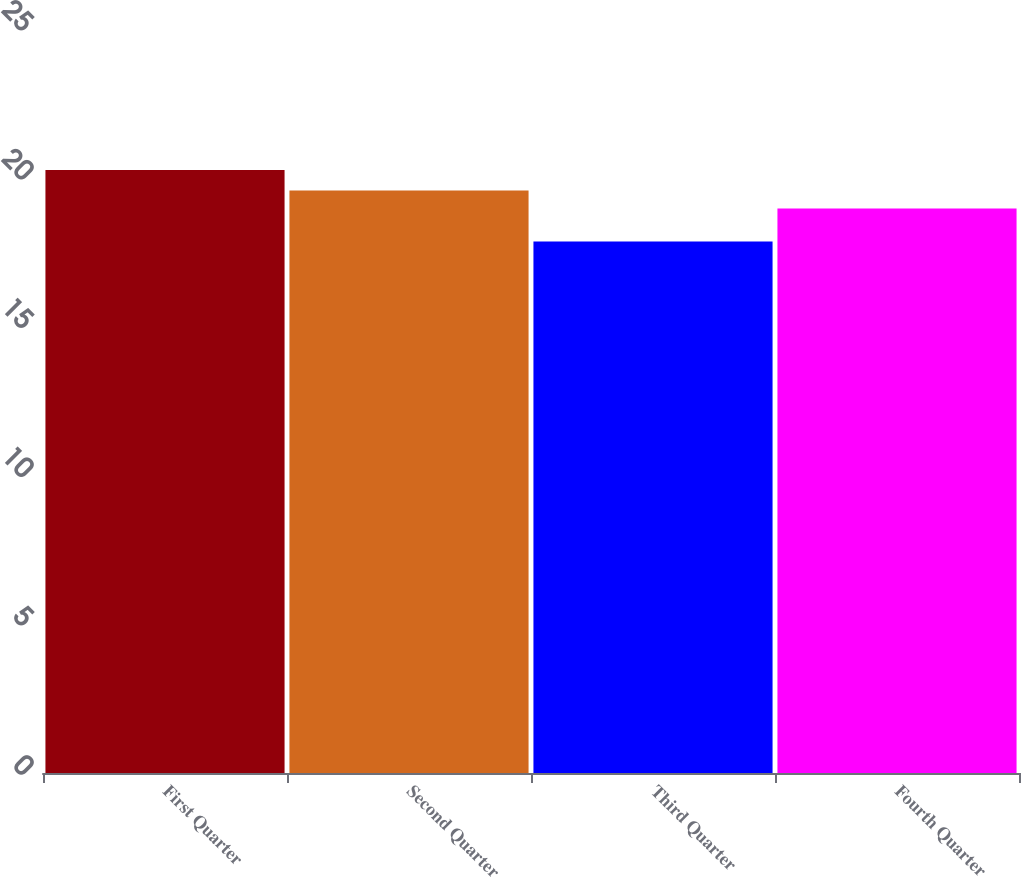<chart> <loc_0><loc_0><loc_500><loc_500><bar_chart><fcel>First Quarter<fcel>Second Quarter<fcel>Third Quarter<fcel>Fourth Quarter<nl><fcel>20.26<fcel>19.57<fcel>17.86<fcel>18.97<nl></chart> 